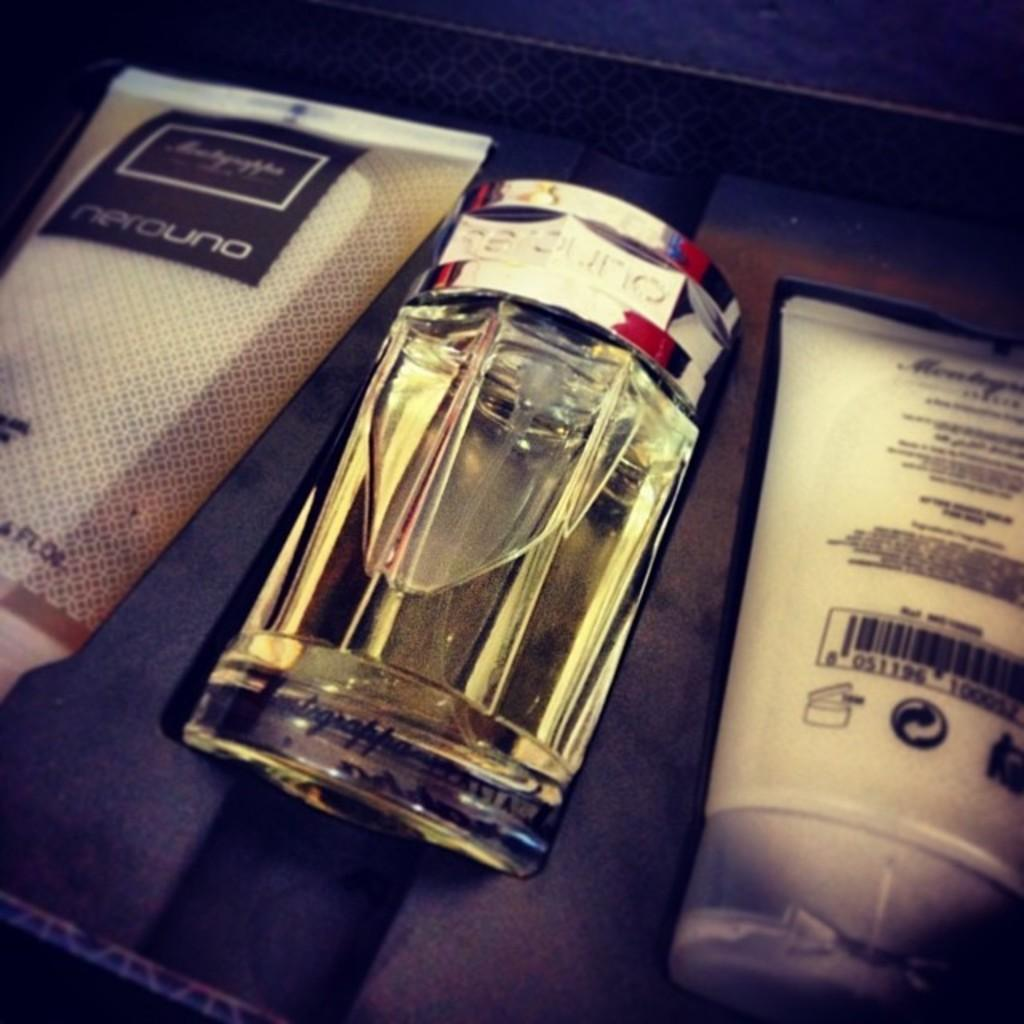<image>
Share a concise interpretation of the image provided. In a gift box of nerouno products, a small bottle sits in the center. 